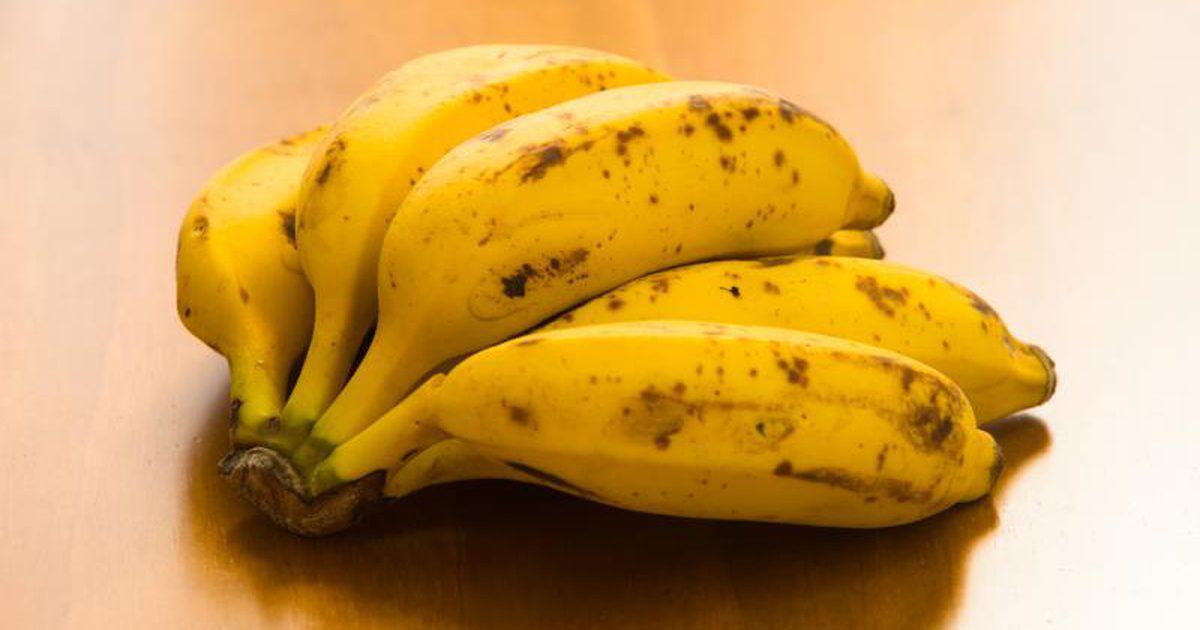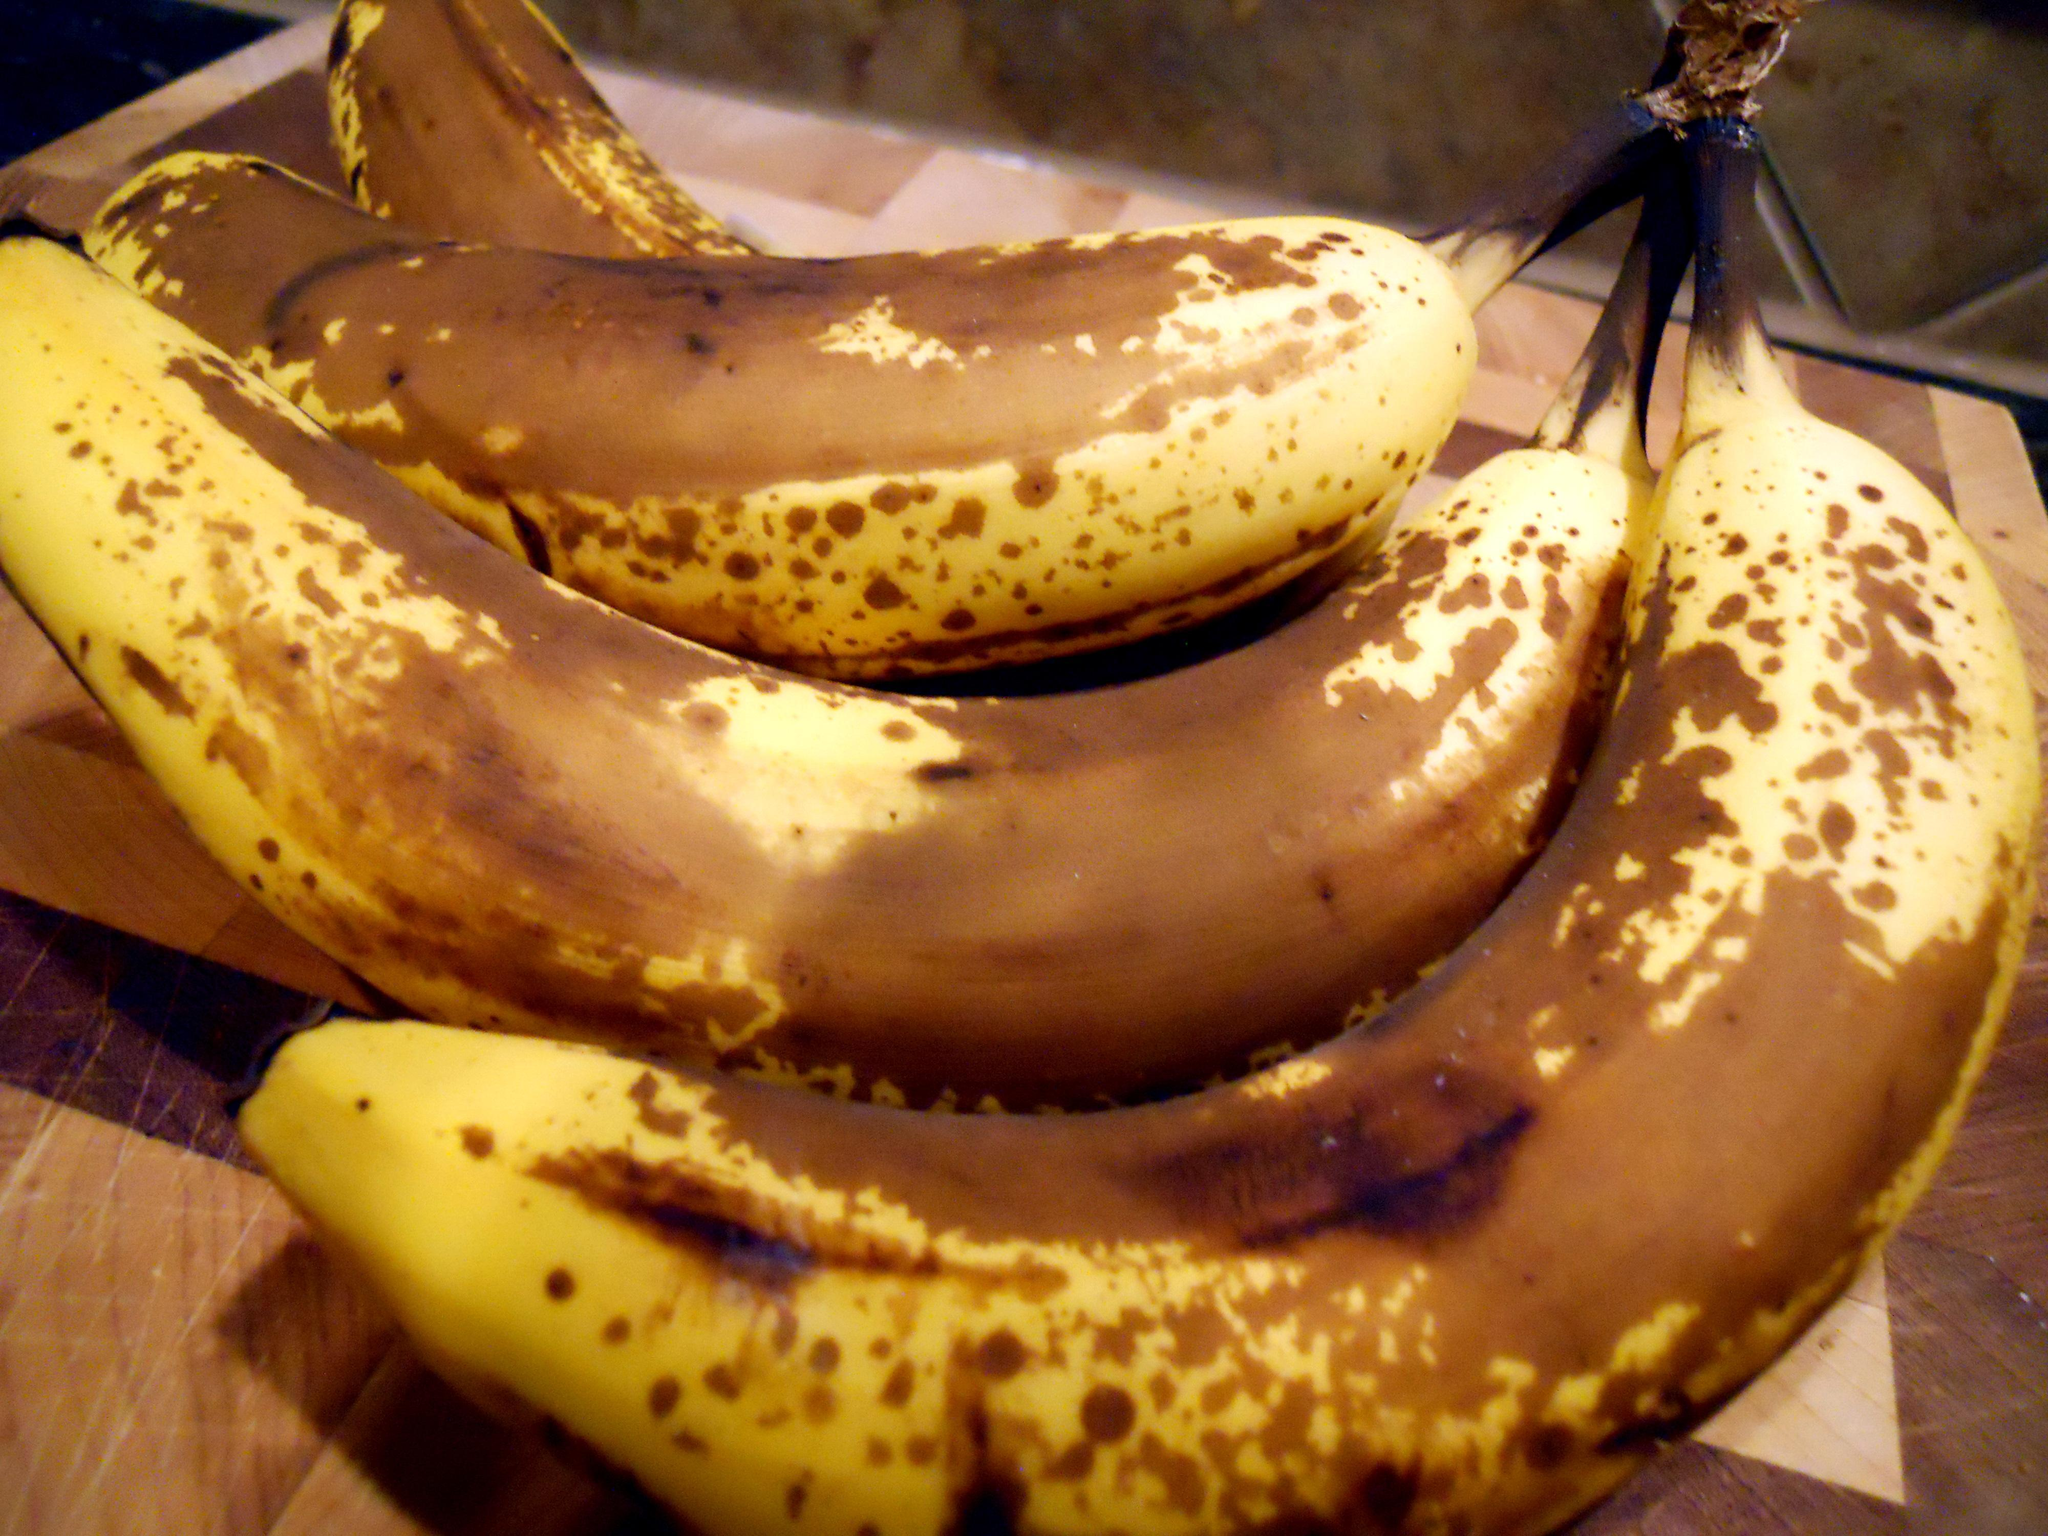The first image is the image on the left, the second image is the image on the right. Examine the images to the left and right. Is the description "The right image shows only overripe, brownish-yellow bananas with their peels intact, and the left image includes bananas and at least one other type of fruit." accurate? Answer yes or no. No. The first image is the image on the left, the second image is the image on the right. For the images shown, is this caption "In the left image bananas are displayed with at least one other type of fruit." true? Answer yes or no. No. 